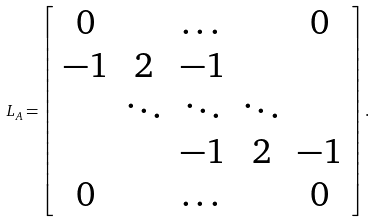Convert formula to latex. <formula><loc_0><loc_0><loc_500><loc_500>L _ { A } = \left [ \begin{array} { c c c c c } 0 & & \dots & & 0 \\ - 1 & 2 & - 1 & & \\ & \ddots & \ddots & \ddots & \\ & & - 1 & 2 & - 1 \\ 0 & & \dots & & 0 \\ \end{array} \right ] .</formula> 